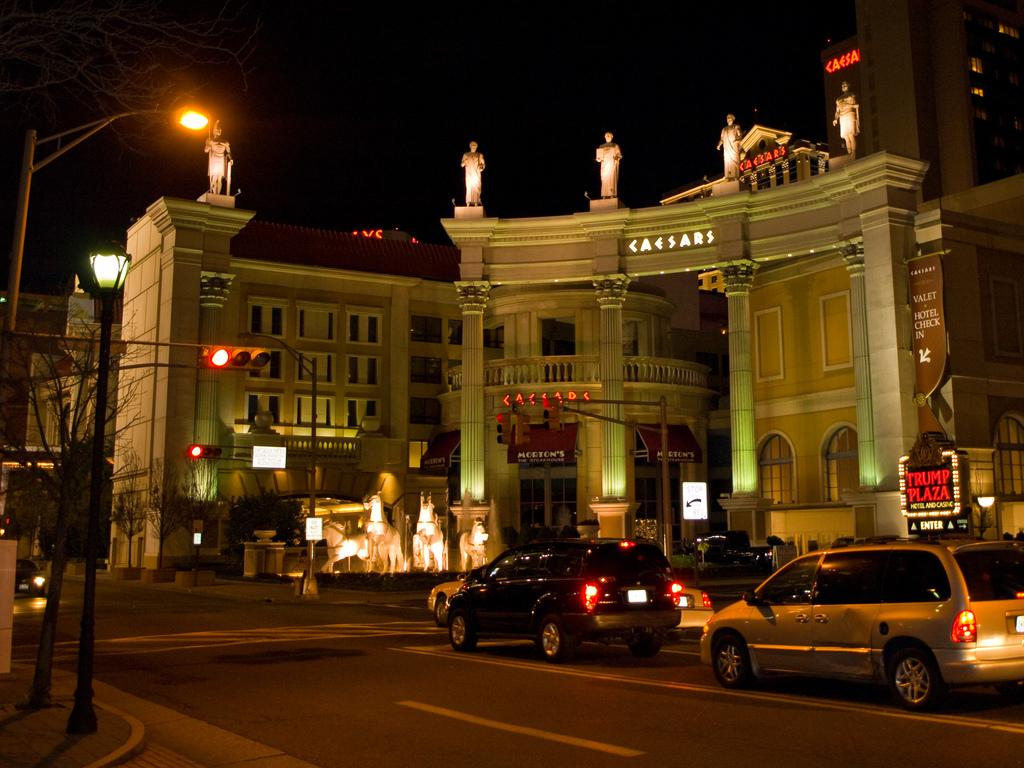Provide a one-sentence caption for the provided image. On a dark night, neon signs identify locations like Trump Plaza and Caesars. 